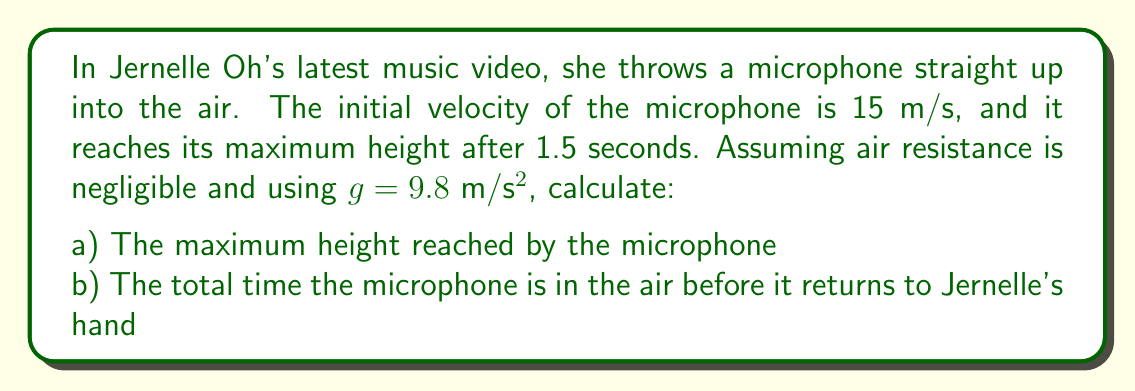Solve this math problem. Let's approach this problem step by step:

1) First, we need to understand the equations of motion for an object thrown vertically upwards:

   $$v = v_0 - gt$$
   $$y = y_0 + v_0t - \frac{1}{2}gt^2$$

   Where $v$ is velocity, $v_0$ is initial velocity, $g$ is acceleration due to gravity, $t$ is time, $y$ is height, and $y_0$ is initial height.

2) We know that at the maximum height, the velocity is zero. We can use this to find the time to reach maximum height:

   $$0 = 15 - 9.8t$$
   $$t = \frac{15}{9.8} = 1.53 \text{ seconds}$$

   This matches the given information that the microphone reaches its maximum height after 1.5 seconds.

3) To find the maximum height (part a), we can use the equation for height:

   $$y = 0 + 15(1.5) - \frac{1}{2}(9.8)(1.5)^2$$
   $$y = 22.5 - 11.025 = 11.475 \text{ meters}$$

4) For part b, we need to find the total time in the air. The time to go up is equal to the time to come down in a symmetrical trajectory. Therefore, the total time is twice the time to reach maximum height:

   $$t_{\text{total}} = 2 * 1.5 = 3 \text{ seconds}$$
Answer: a) The maximum height reached by the microphone is 11.475 meters.
b) The total time the microphone is in the air is 3 seconds. 